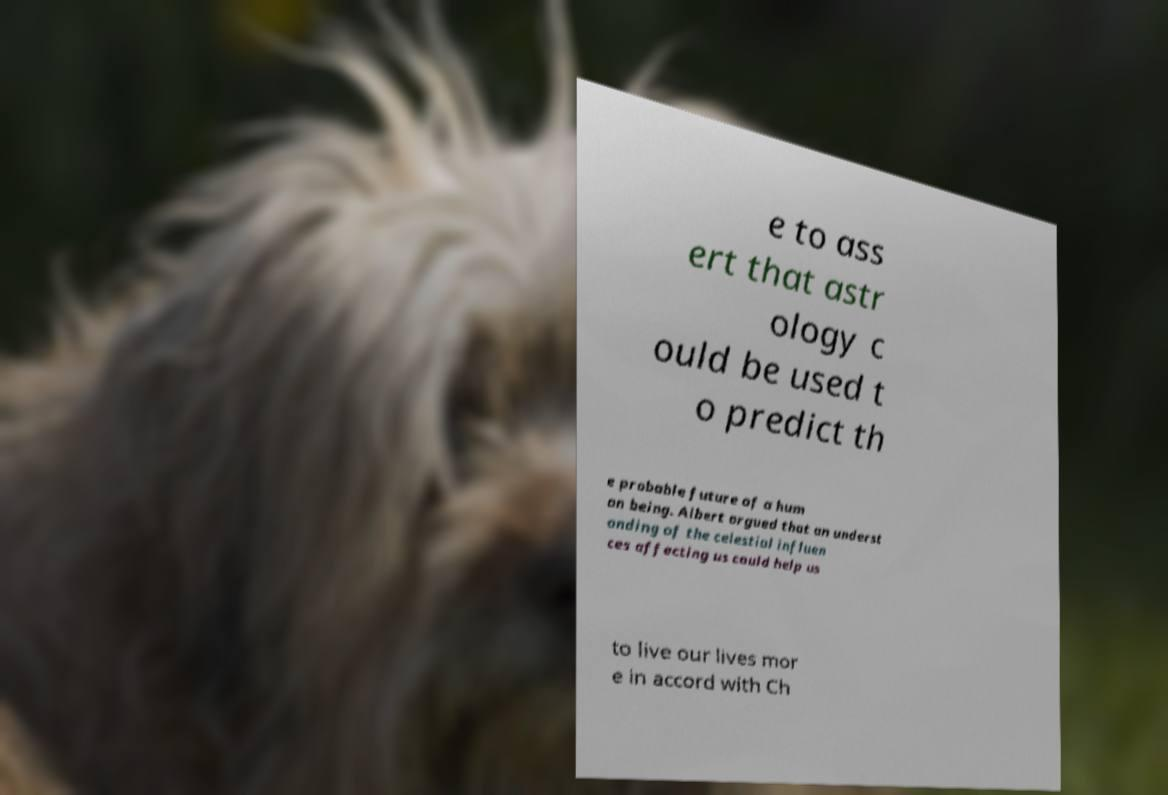For documentation purposes, I need the text within this image transcribed. Could you provide that? e to ass ert that astr ology c ould be used t o predict th e probable future of a hum an being. Albert argued that an underst anding of the celestial influen ces affecting us could help us to live our lives mor e in accord with Ch 